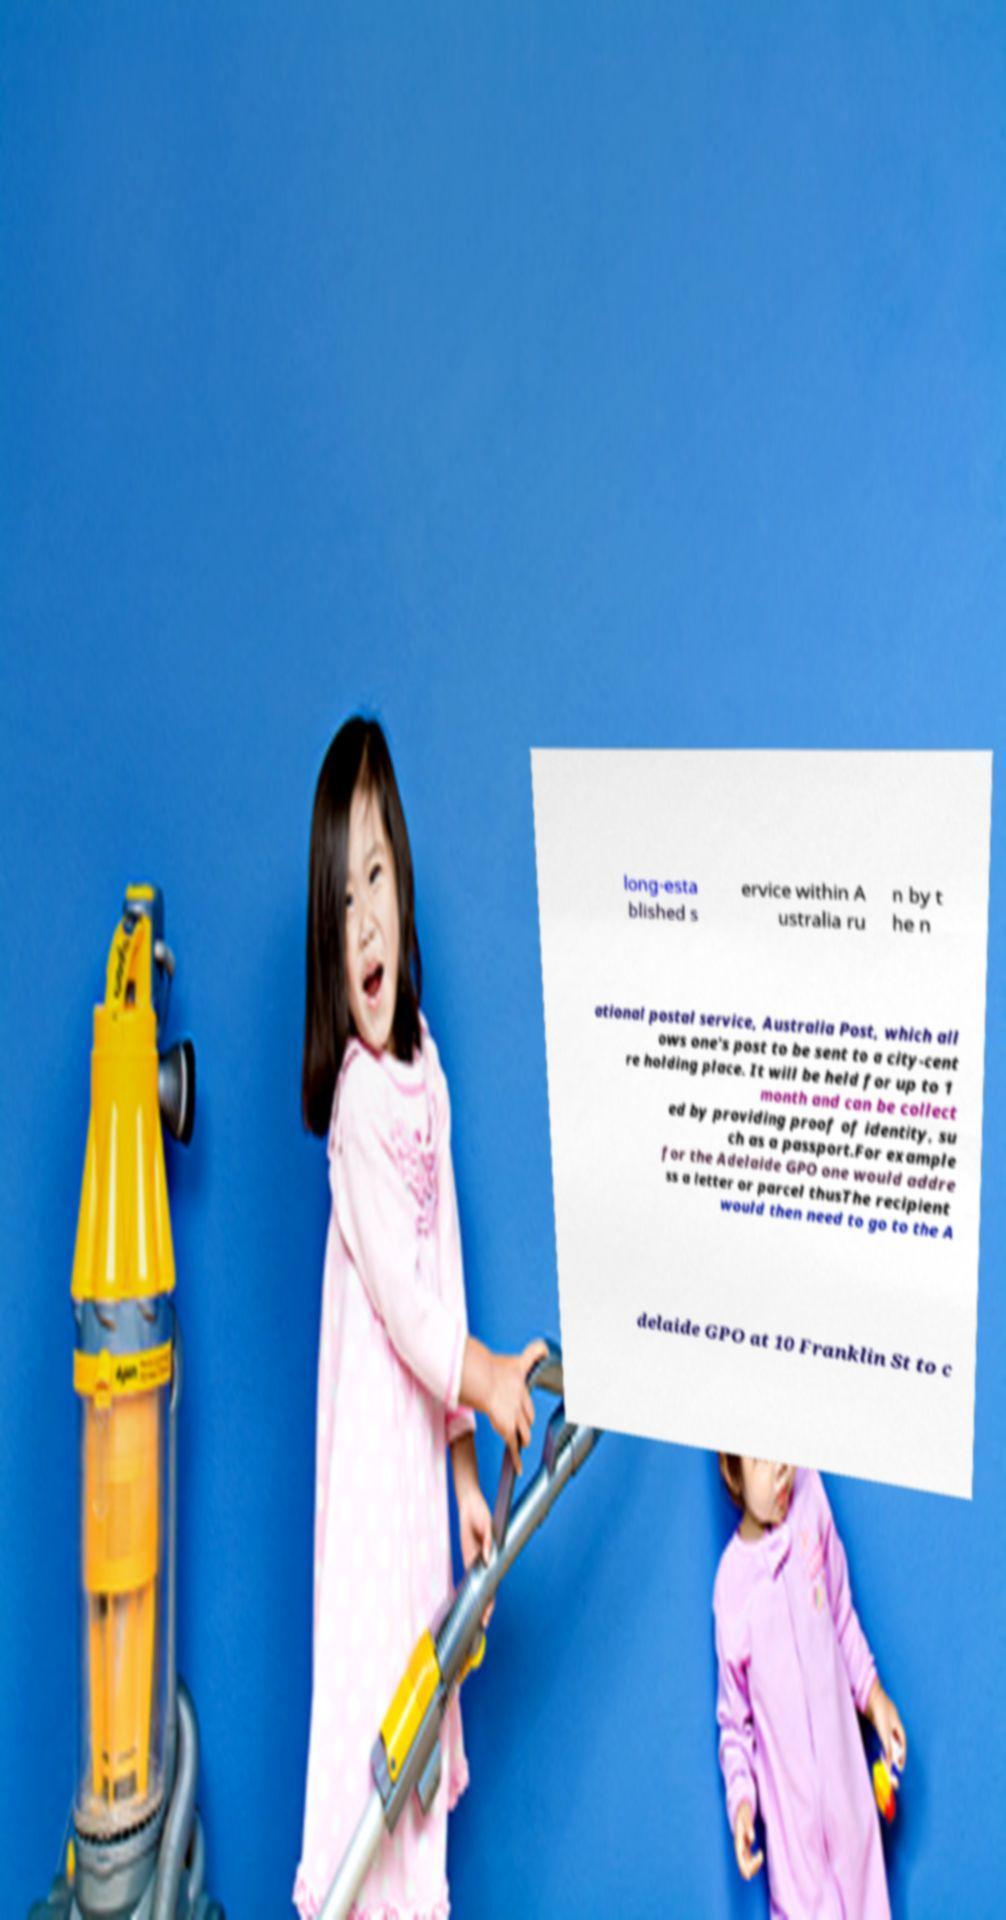Could you extract and type out the text from this image? long-esta blished s ervice within A ustralia ru n by t he n ational postal service, Australia Post, which all ows one's post to be sent to a city-cent re holding place. It will be held for up to 1 month and can be collect ed by providing proof of identity, su ch as a passport.For example for the Adelaide GPO one would addre ss a letter or parcel thusThe recipient would then need to go to the A delaide GPO at 10 Franklin St to c 